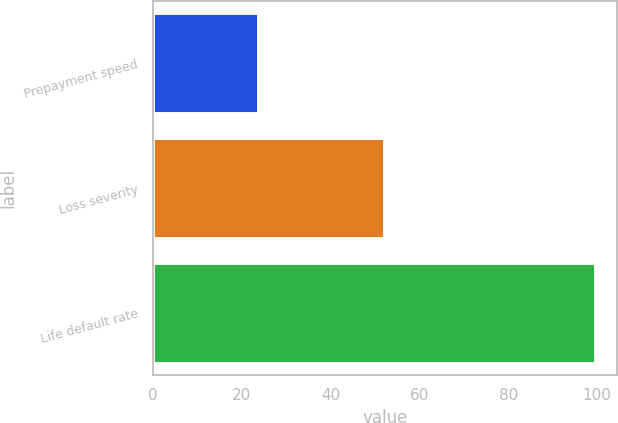Convert chart. <chart><loc_0><loc_0><loc_500><loc_500><bar_chart><fcel>Prepayment speed<fcel>Loss severity<fcel>Life default rate<nl><fcel>23.6<fcel>52.1<fcel>99.6<nl></chart> 